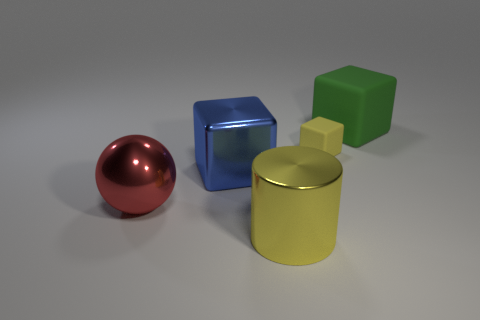Subtract all cubes. How many objects are left? 2 Add 5 green cubes. How many objects exist? 10 Subtract all large blocks. How many blocks are left? 1 Subtract 0 brown blocks. How many objects are left? 5 Subtract 1 cylinders. How many cylinders are left? 0 Subtract all yellow balls. Subtract all red cylinders. How many balls are left? 1 Subtract all red cubes. How many gray balls are left? 0 Subtract all large green matte things. Subtract all large matte blocks. How many objects are left? 3 Add 1 big green rubber cubes. How many big green rubber cubes are left? 2 Add 5 small purple shiny things. How many small purple shiny things exist? 5 